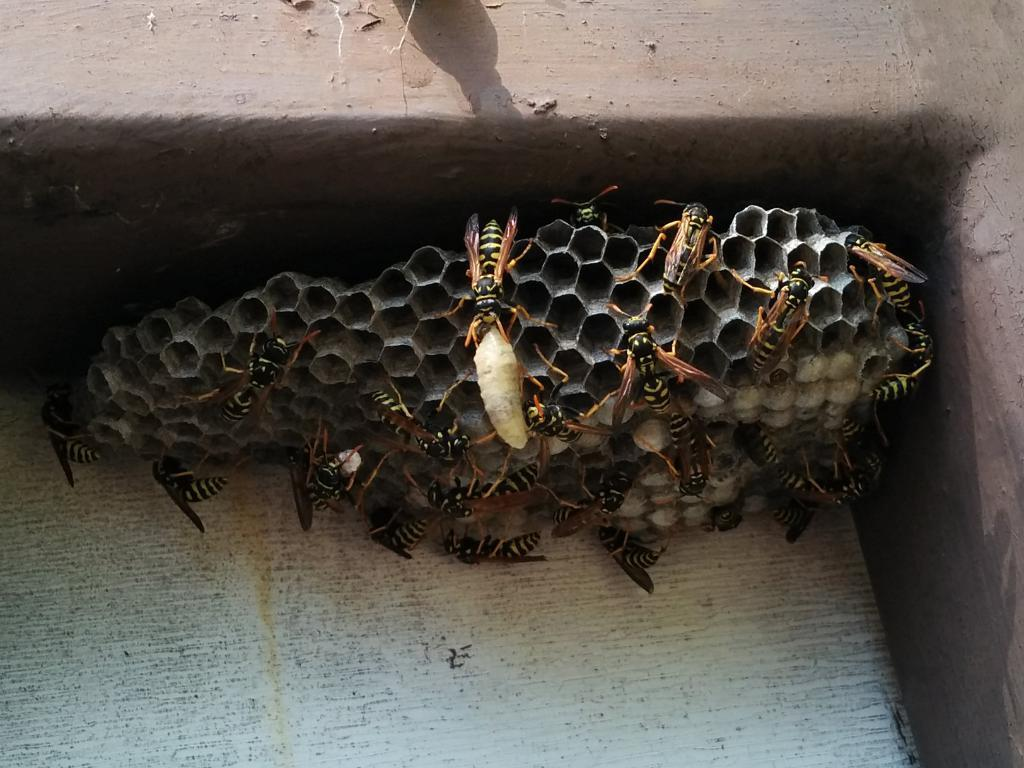What is the main subject of the image? The main subject of the image is a honeycomb. Are there any other living organisms present in the image? Yes, there are honey bees in the image. What type of friction can be observed between the beetle and the honeycomb in the image? There is no beetle present in the image, so friction between a beetle and the honeycomb cannot be observed. 